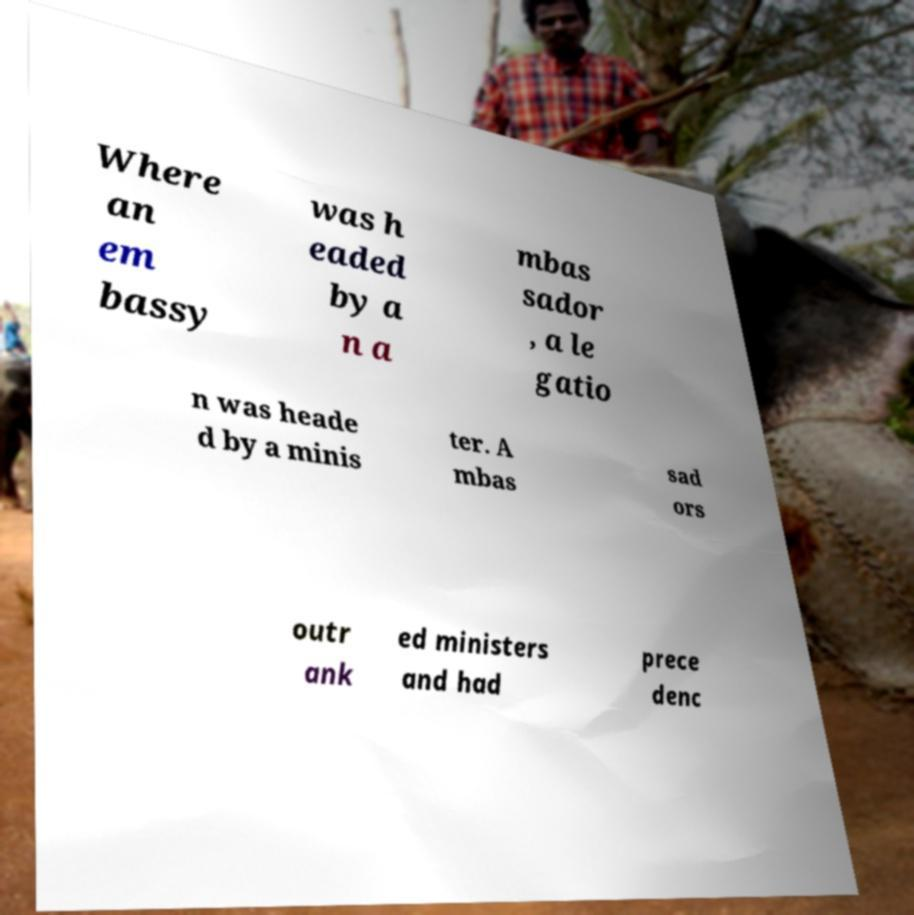There's text embedded in this image that I need extracted. Can you transcribe it verbatim? Where an em bassy was h eaded by a n a mbas sador , a le gatio n was heade d by a minis ter. A mbas sad ors outr ank ed ministers and had prece denc 